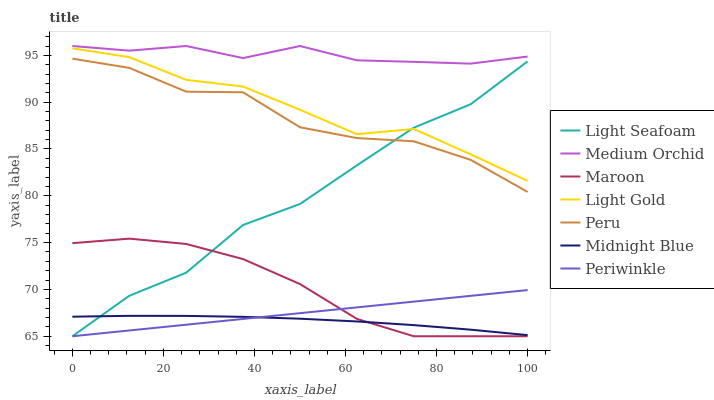Does Midnight Blue have the minimum area under the curve?
Answer yes or no. Yes. Does Medium Orchid have the maximum area under the curve?
Answer yes or no. Yes. Does Maroon have the minimum area under the curve?
Answer yes or no. No. Does Maroon have the maximum area under the curve?
Answer yes or no. No. Is Periwinkle the smoothest?
Answer yes or no. Yes. Is Peru the roughest?
Answer yes or no. Yes. Is Medium Orchid the smoothest?
Answer yes or no. No. Is Medium Orchid the roughest?
Answer yes or no. No. Does Medium Orchid have the lowest value?
Answer yes or no. No. Does Medium Orchid have the highest value?
Answer yes or no. Yes. Does Maroon have the highest value?
Answer yes or no. No. Is Midnight Blue less than Peru?
Answer yes or no. Yes. Is Medium Orchid greater than Periwinkle?
Answer yes or no. Yes. Does Maroon intersect Periwinkle?
Answer yes or no. Yes. Is Maroon less than Periwinkle?
Answer yes or no. No. Is Maroon greater than Periwinkle?
Answer yes or no. No. Does Midnight Blue intersect Peru?
Answer yes or no. No. 